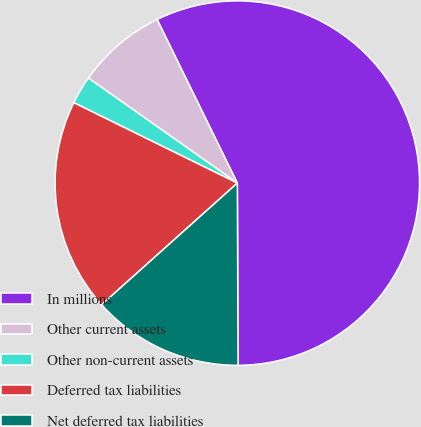Convert chart to OTSL. <chart><loc_0><loc_0><loc_500><loc_500><pie_chart><fcel>In millions<fcel>Other current assets<fcel>Other non-current assets<fcel>Deferred tax liabilities<fcel>Net deferred tax liabilities<nl><fcel>57.2%<fcel>7.97%<fcel>2.5%<fcel>18.91%<fcel>13.44%<nl></chart> 